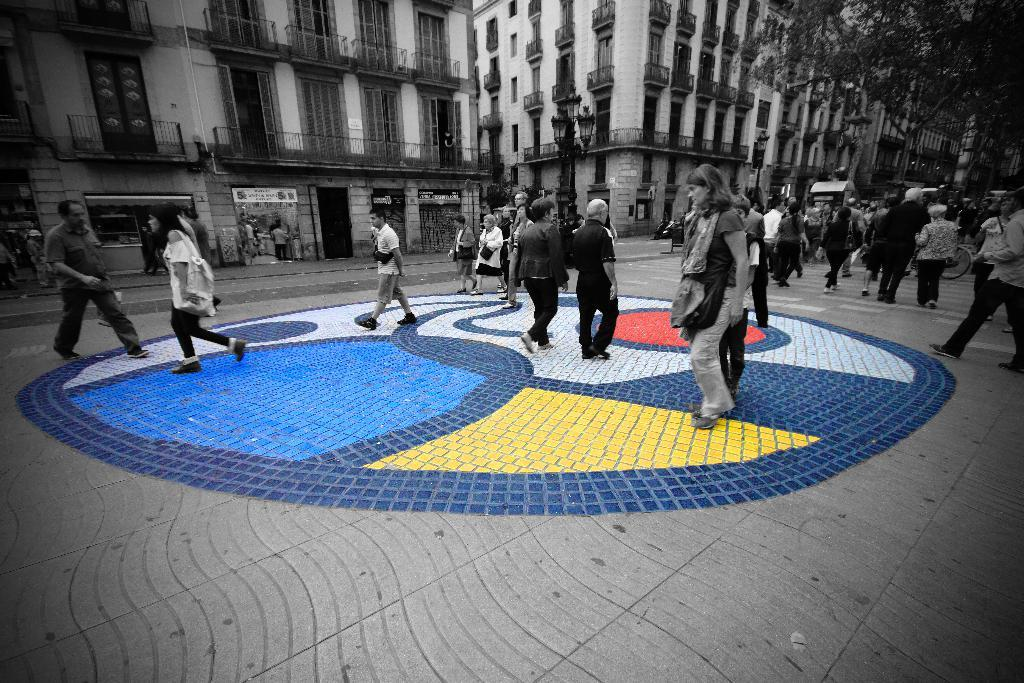What are the people in the image doing? The people in the image are walking on the road. What can be seen in the distance in the image? There are buildings and trees in the background of the image. What type of cloud can be seen in the image? There is no cloud visible in the image; it only features people walking on the road, buildings, and trees in the background. 